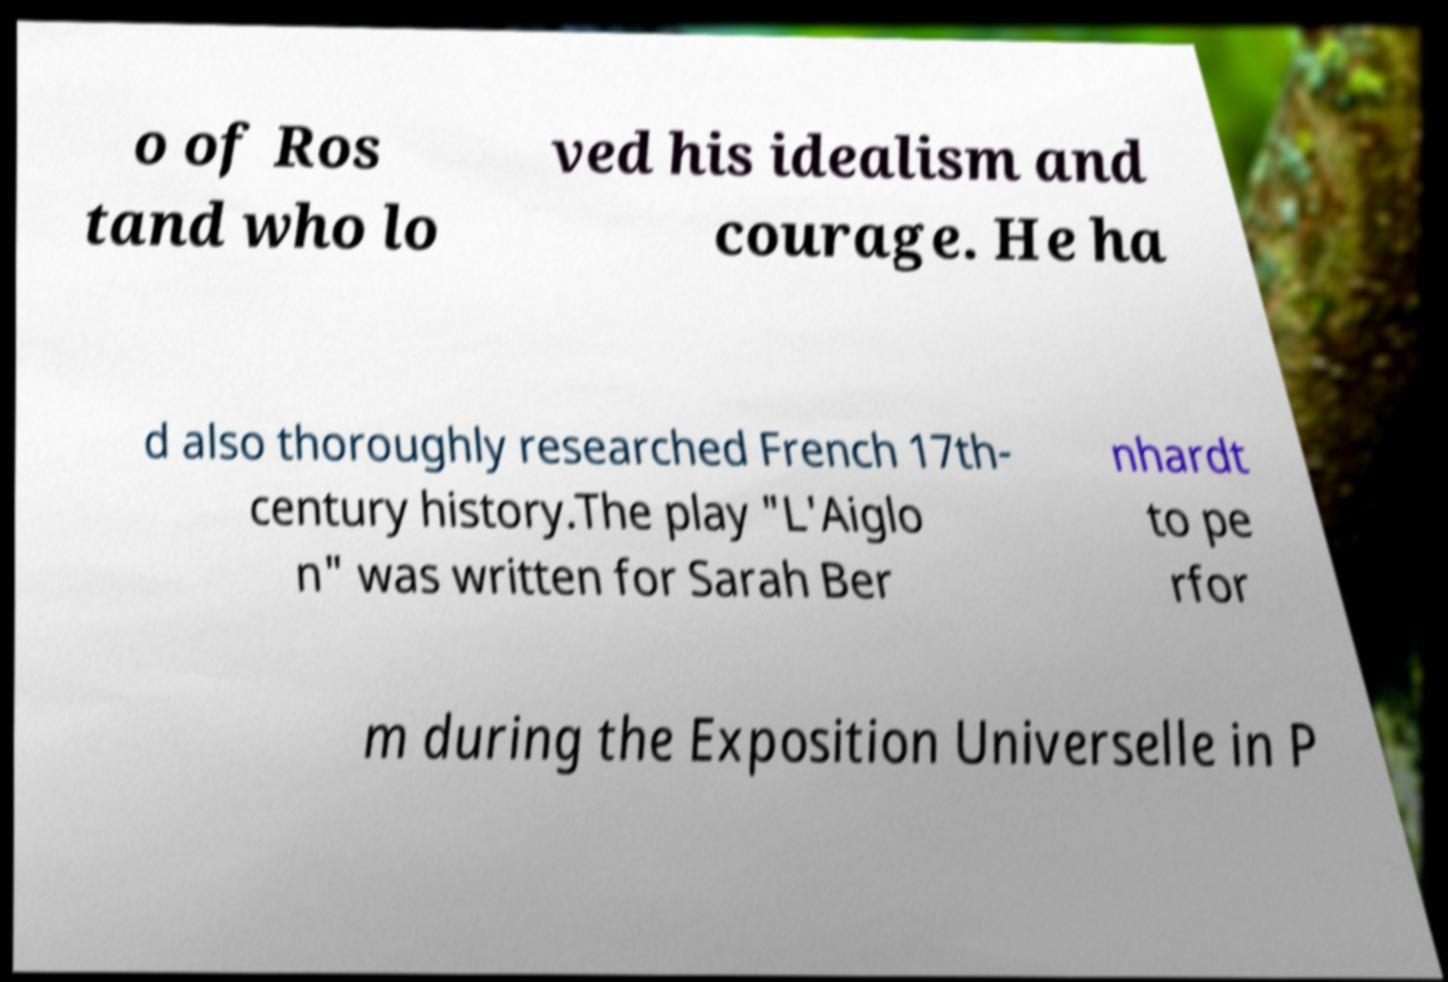Could you extract and type out the text from this image? o of Ros tand who lo ved his idealism and courage. He ha d also thoroughly researched French 17th- century history.The play "L'Aiglo n" was written for Sarah Ber nhardt to pe rfor m during the Exposition Universelle in P 